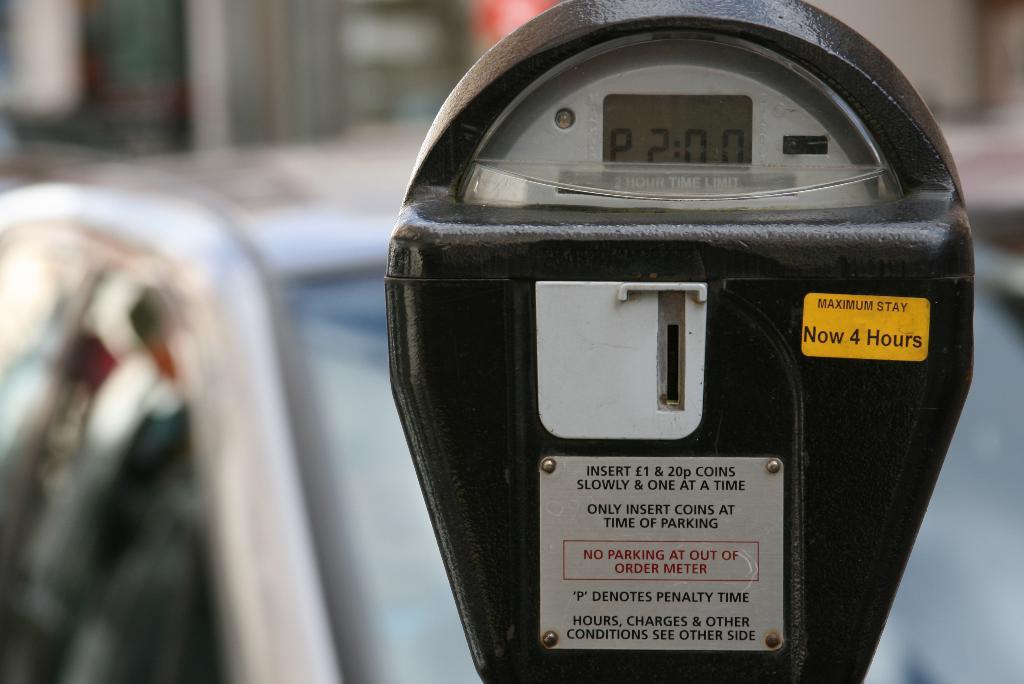How many hours is the maximum stay?
Ensure brevity in your answer.  4. How many coins does it say to enter at a time?
Provide a succinct answer. One. 